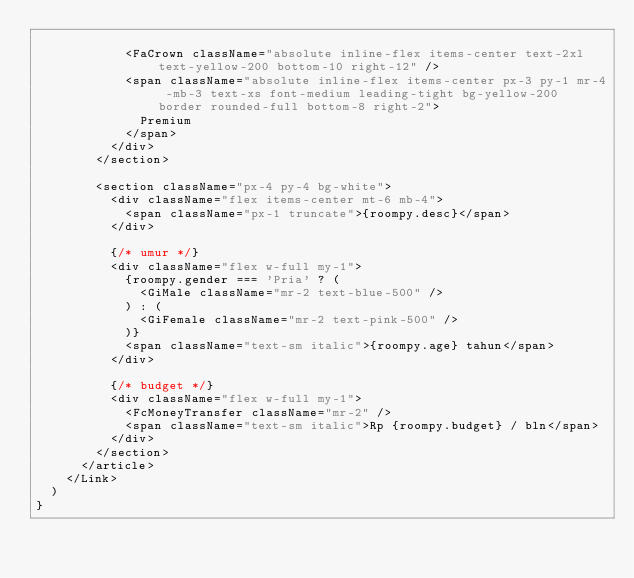<code> <loc_0><loc_0><loc_500><loc_500><_TypeScript_>
            <FaCrown className="absolute inline-flex items-center text-2xl text-yellow-200 bottom-10 right-12" />
            <span className="absolute inline-flex items-center px-3 py-1 mr-4 -mb-3 text-xs font-medium leading-tight bg-yellow-200 border rounded-full bottom-8 right-2">
              Premium
            </span>
          </div>
        </section>

        <section className="px-4 py-4 bg-white">
          <div className="flex items-center mt-6 mb-4">
            <span className="px-1 truncate">{roompy.desc}</span>
          </div>

          {/* umur */}
          <div className="flex w-full my-1">
            {roompy.gender === 'Pria' ? (
              <GiMale className="mr-2 text-blue-500" />
            ) : (
              <GiFemale className="mr-2 text-pink-500" />
            )}
            <span className="text-sm italic">{roompy.age} tahun</span>
          </div>

          {/* budget */}
          <div className="flex w-full my-1">
            <FcMoneyTransfer className="mr-2" />
            <span className="text-sm italic">Rp {roompy.budget} / bln</span>
          </div>
        </section>
      </article>
    </Link>
  )
}
</code> 